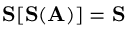<formula> <loc_0><loc_0><loc_500><loc_500>S [ S ( A ) ] = S</formula> 